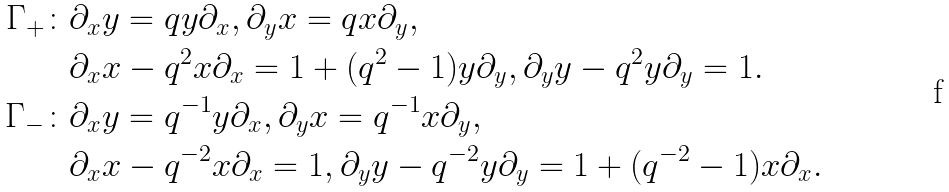<formula> <loc_0><loc_0><loc_500><loc_500>\Gamma _ { + } \colon & \partial _ { x } y = q y \partial _ { x } , \partial _ { y } x = q x \partial _ { y } , \\ & \partial _ { x } x - q ^ { 2 } x \partial _ { x } = 1 + ( q ^ { 2 } - 1 ) y \partial _ { y } , \partial _ { y } y - q ^ { 2 } y \partial _ { y } = 1 . \\ \Gamma _ { - } \colon & \partial _ { x } y = q ^ { - 1 } y \partial _ { x } , \partial _ { y } x = q ^ { - 1 } x \partial _ { y } , \\ & \partial _ { x } x - q ^ { - 2 } x \partial _ { x } = 1 , \partial _ { y } y - q ^ { - 2 } y \partial _ { y } = 1 + ( q ^ { - 2 } - 1 ) x \partial _ { x } .</formula> 